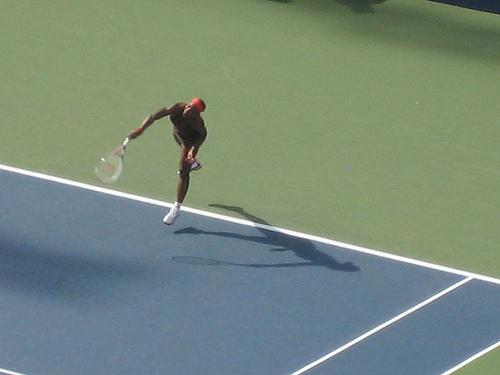Question: how is the person's head positioned?
Choices:
A. Looking straight ahead.
B. Looking up.
C. Looking down.
D. Askew.
Answer with the letter. Answer: B Question: what might the person be looking up at?
Choices:
A. Football.
B. Golf ball.
C. Tennis ball.
D. Baseball.
Answer with the letter. Answer: C Question: why does the person have a racket in his hand?
Choices:
A. To block the ball.
B. For self-defense.
C. To swat insects.
D. To hit ball.
Answer with the letter. Answer: D Question: who does this person appear to be?
Choices:
A. Teen.
B. Man.
C. Adolescent.
D. Senior citizen.
Answer with the letter. Answer: B 